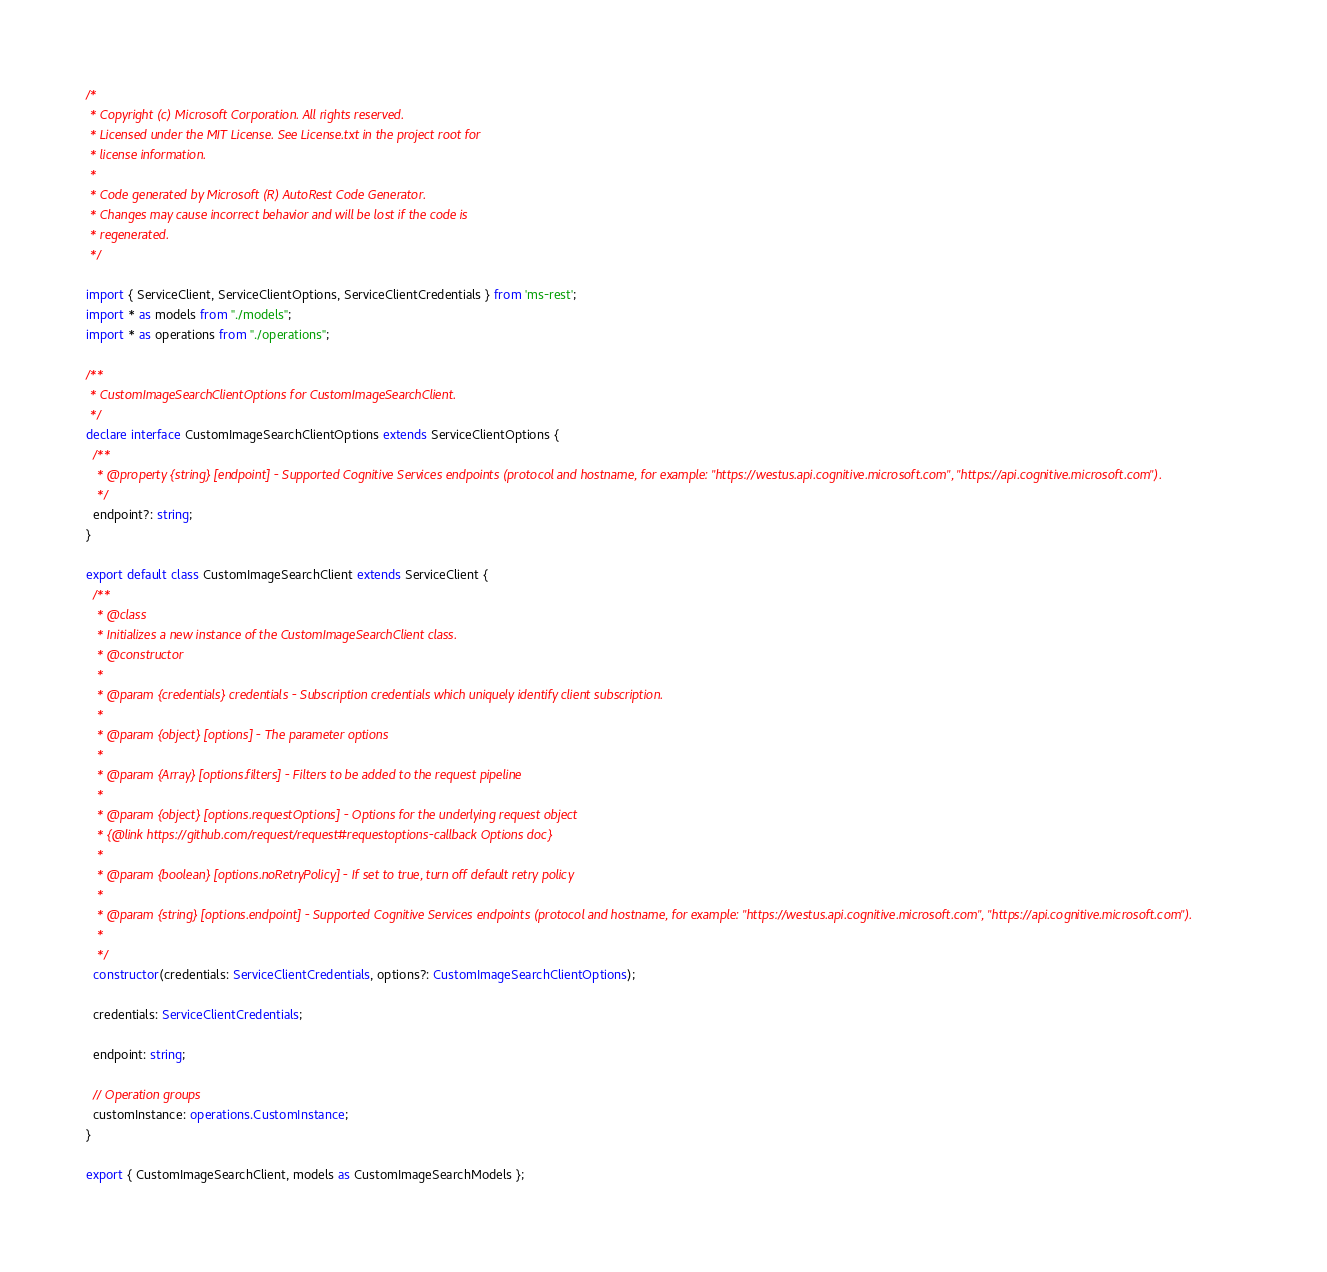<code> <loc_0><loc_0><loc_500><loc_500><_TypeScript_>/*
 * Copyright (c) Microsoft Corporation. All rights reserved.
 * Licensed under the MIT License. See License.txt in the project root for
 * license information.
 *
 * Code generated by Microsoft (R) AutoRest Code Generator.
 * Changes may cause incorrect behavior and will be lost if the code is
 * regenerated.
 */

import { ServiceClient, ServiceClientOptions, ServiceClientCredentials } from 'ms-rest';
import * as models from "./models";
import * as operations from "./operations";

/**
 * CustomImageSearchClientOptions for CustomImageSearchClient.
 */
declare interface CustomImageSearchClientOptions extends ServiceClientOptions {
  /**
   * @property {string} [endpoint] - Supported Cognitive Services endpoints (protocol and hostname, for example: "https://westus.api.cognitive.microsoft.com", "https://api.cognitive.microsoft.com").
   */
  endpoint?: string;
}

export default class CustomImageSearchClient extends ServiceClient {
  /**
   * @class
   * Initializes a new instance of the CustomImageSearchClient class.
   * @constructor
   *
   * @param {credentials} credentials - Subscription credentials which uniquely identify client subscription.
   *
   * @param {object} [options] - The parameter options
   *
   * @param {Array} [options.filters] - Filters to be added to the request pipeline
   *
   * @param {object} [options.requestOptions] - Options for the underlying request object
   * {@link https://github.com/request/request#requestoptions-callback Options doc}
   *
   * @param {boolean} [options.noRetryPolicy] - If set to true, turn off default retry policy
   *
   * @param {string} [options.endpoint] - Supported Cognitive Services endpoints (protocol and hostname, for example: "https://westus.api.cognitive.microsoft.com", "https://api.cognitive.microsoft.com").
   *
   */
  constructor(credentials: ServiceClientCredentials, options?: CustomImageSearchClientOptions);

  credentials: ServiceClientCredentials;

  endpoint: string;

  // Operation groups
  customInstance: operations.CustomInstance;
}

export { CustomImageSearchClient, models as CustomImageSearchModels };
</code> 